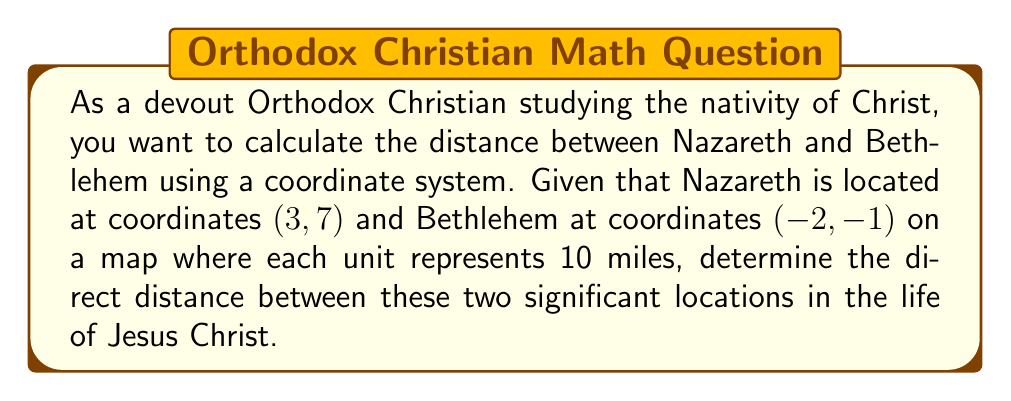Can you answer this question? To calculate the distance between two points on a coordinate plane, we use the distance formula, which is derived from the Pythagorean theorem:

$$ d = \sqrt{(x_2 - x_1)^2 + (y_2 - y_1)^2} $$

Where $(x_1, y_1)$ represents the coordinates of the first point (Nazareth) and $(x_2, y_2)$ represents the coordinates of the second point (Bethlehem).

Let's plug in the given coordinates:
Nazareth: $(x_1, y_1) = (3, 7)$
Bethlehem: $(x_2, y_2) = (-2, -1)$

Now, let's substitute these values into the formula:

$$ d = \sqrt{(-2 - 3)^2 + (-1 - 7)^2} $$

Simplify the expressions inside the parentheses:

$$ d = \sqrt{(-5)^2 + (-8)^2} $$

Calculate the squares:

$$ d = \sqrt{25 + 64} $$

Add the values under the square root:

$$ d = \sqrt{89} $$

The square root of 89 is approximately 9.434.

Since each unit represents 10 miles, we need to multiply our result by 10:

$$ 9.434 \times 10 = 94.34 \text{ miles} $$

[asy]
unitsize(10);
draw((-3,-2)--(4,8), gray);
dot((3,7), red);
dot((-2,-1), blue);
label("Nazareth (3, 7)", (3,7), NE, red);
label("Bethlehem (-2, -1)", (-2,-1), SW, blue);
label("94.34 miles", (0.5,3), SE, black);
[/asy]
Answer: The direct distance between Nazareth and Bethlehem is approximately 94.34 miles. 